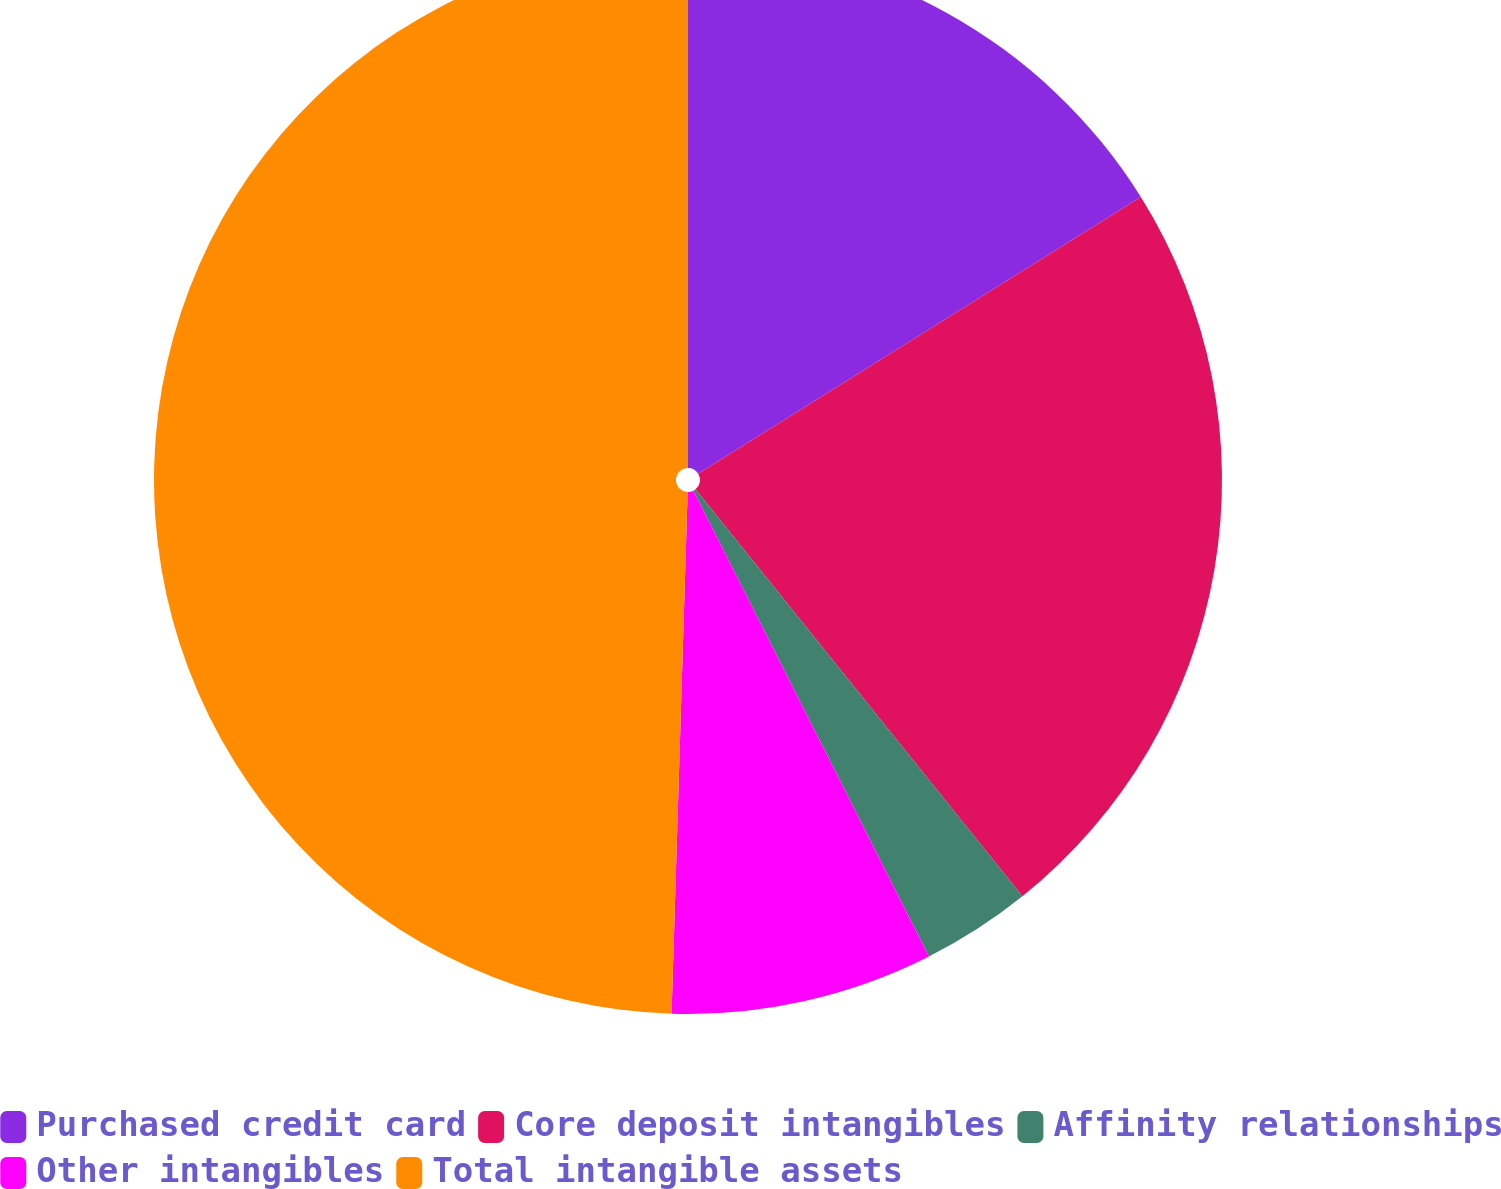<chart> <loc_0><loc_0><loc_500><loc_500><pie_chart><fcel>Purchased credit card<fcel>Core deposit intangibles<fcel>Affinity relationships<fcel>Other intangibles<fcel>Total intangible assets<nl><fcel>16.11%<fcel>23.12%<fcel>3.32%<fcel>7.94%<fcel>49.51%<nl></chart> 